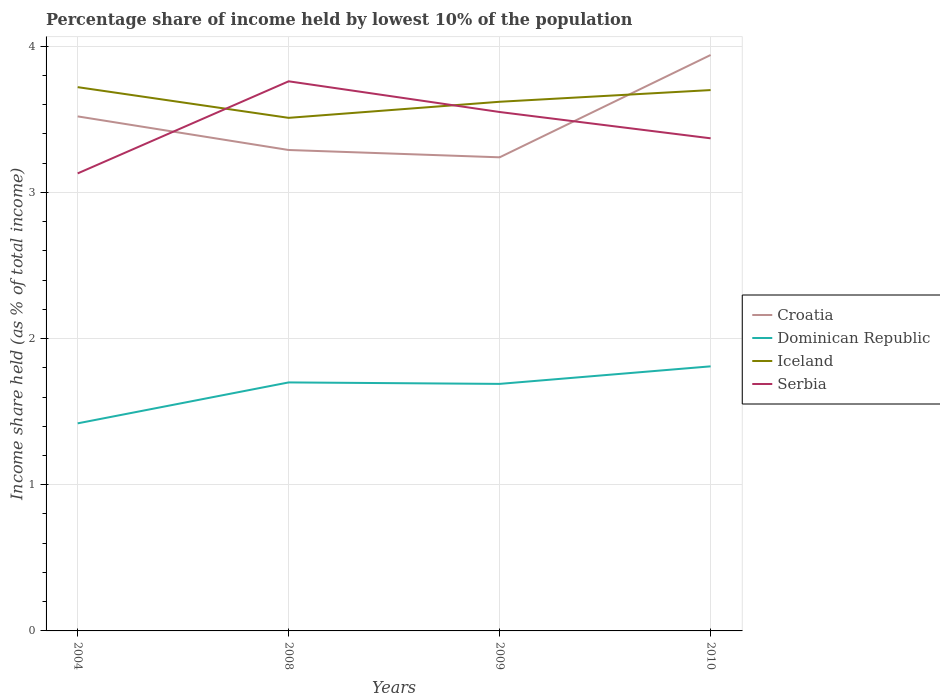How many different coloured lines are there?
Provide a succinct answer. 4. Does the line corresponding to Dominican Republic intersect with the line corresponding to Serbia?
Your response must be concise. No. Is the number of lines equal to the number of legend labels?
Give a very brief answer. Yes. Across all years, what is the maximum percentage share of income held by lowest 10% of the population in Croatia?
Offer a terse response. 3.24. In which year was the percentage share of income held by lowest 10% of the population in Iceland maximum?
Provide a short and direct response. 2008. What is the total percentage share of income held by lowest 10% of the population in Dominican Republic in the graph?
Your answer should be very brief. 0.01. What is the difference between the highest and the second highest percentage share of income held by lowest 10% of the population in Serbia?
Make the answer very short. 0.63. How many lines are there?
Your response must be concise. 4. How many years are there in the graph?
Keep it short and to the point. 4. Are the values on the major ticks of Y-axis written in scientific E-notation?
Offer a very short reply. No. Does the graph contain any zero values?
Your response must be concise. No. What is the title of the graph?
Keep it short and to the point. Percentage share of income held by lowest 10% of the population. Does "Gambia, The" appear as one of the legend labels in the graph?
Your answer should be very brief. No. What is the label or title of the Y-axis?
Your response must be concise. Income share held (as % of total income). What is the Income share held (as % of total income) in Croatia in 2004?
Give a very brief answer. 3.52. What is the Income share held (as % of total income) of Dominican Republic in 2004?
Offer a terse response. 1.42. What is the Income share held (as % of total income) of Iceland in 2004?
Your answer should be compact. 3.72. What is the Income share held (as % of total income) in Serbia in 2004?
Give a very brief answer. 3.13. What is the Income share held (as % of total income) in Croatia in 2008?
Offer a very short reply. 3.29. What is the Income share held (as % of total income) in Dominican Republic in 2008?
Provide a succinct answer. 1.7. What is the Income share held (as % of total income) in Iceland in 2008?
Offer a terse response. 3.51. What is the Income share held (as % of total income) in Serbia in 2008?
Keep it short and to the point. 3.76. What is the Income share held (as % of total income) in Croatia in 2009?
Give a very brief answer. 3.24. What is the Income share held (as % of total income) of Dominican Republic in 2009?
Keep it short and to the point. 1.69. What is the Income share held (as % of total income) in Iceland in 2009?
Offer a terse response. 3.62. What is the Income share held (as % of total income) of Serbia in 2009?
Your answer should be very brief. 3.55. What is the Income share held (as % of total income) of Croatia in 2010?
Keep it short and to the point. 3.94. What is the Income share held (as % of total income) in Dominican Republic in 2010?
Provide a short and direct response. 1.81. What is the Income share held (as % of total income) of Serbia in 2010?
Ensure brevity in your answer.  3.37. Across all years, what is the maximum Income share held (as % of total income) in Croatia?
Your answer should be very brief. 3.94. Across all years, what is the maximum Income share held (as % of total income) of Dominican Republic?
Offer a very short reply. 1.81. Across all years, what is the maximum Income share held (as % of total income) in Iceland?
Give a very brief answer. 3.72. Across all years, what is the maximum Income share held (as % of total income) in Serbia?
Your response must be concise. 3.76. Across all years, what is the minimum Income share held (as % of total income) of Croatia?
Ensure brevity in your answer.  3.24. Across all years, what is the minimum Income share held (as % of total income) of Dominican Republic?
Provide a succinct answer. 1.42. Across all years, what is the minimum Income share held (as % of total income) of Iceland?
Offer a very short reply. 3.51. Across all years, what is the minimum Income share held (as % of total income) of Serbia?
Your answer should be very brief. 3.13. What is the total Income share held (as % of total income) of Croatia in the graph?
Provide a short and direct response. 13.99. What is the total Income share held (as % of total income) of Dominican Republic in the graph?
Offer a very short reply. 6.62. What is the total Income share held (as % of total income) of Iceland in the graph?
Provide a short and direct response. 14.55. What is the total Income share held (as % of total income) of Serbia in the graph?
Provide a succinct answer. 13.81. What is the difference between the Income share held (as % of total income) of Croatia in 2004 and that in 2008?
Provide a succinct answer. 0.23. What is the difference between the Income share held (as % of total income) of Dominican Republic in 2004 and that in 2008?
Make the answer very short. -0.28. What is the difference between the Income share held (as % of total income) of Iceland in 2004 and that in 2008?
Give a very brief answer. 0.21. What is the difference between the Income share held (as % of total income) of Serbia in 2004 and that in 2008?
Make the answer very short. -0.63. What is the difference between the Income share held (as % of total income) of Croatia in 2004 and that in 2009?
Make the answer very short. 0.28. What is the difference between the Income share held (as % of total income) of Dominican Republic in 2004 and that in 2009?
Make the answer very short. -0.27. What is the difference between the Income share held (as % of total income) of Iceland in 2004 and that in 2009?
Make the answer very short. 0.1. What is the difference between the Income share held (as % of total income) of Serbia in 2004 and that in 2009?
Give a very brief answer. -0.42. What is the difference between the Income share held (as % of total income) in Croatia in 2004 and that in 2010?
Offer a terse response. -0.42. What is the difference between the Income share held (as % of total income) in Dominican Republic in 2004 and that in 2010?
Make the answer very short. -0.39. What is the difference between the Income share held (as % of total income) in Iceland in 2004 and that in 2010?
Keep it short and to the point. 0.02. What is the difference between the Income share held (as % of total income) in Serbia in 2004 and that in 2010?
Make the answer very short. -0.24. What is the difference between the Income share held (as % of total income) in Dominican Republic in 2008 and that in 2009?
Your response must be concise. 0.01. What is the difference between the Income share held (as % of total income) in Iceland in 2008 and that in 2009?
Provide a short and direct response. -0.11. What is the difference between the Income share held (as % of total income) in Serbia in 2008 and that in 2009?
Keep it short and to the point. 0.21. What is the difference between the Income share held (as % of total income) of Croatia in 2008 and that in 2010?
Provide a short and direct response. -0.65. What is the difference between the Income share held (as % of total income) of Dominican Republic in 2008 and that in 2010?
Your answer should be very brief. -0.11. What is the difference between the Income share held (as % of total income) in Iceland in 2008 and that in 2010?
Your answer should be very brief. -0.19. What is the difference between the Income share held (as % of total income) in Serbia in 2008 and that in 2010?
Your answer should be very brief. 0.39. What is the difference between the Income share held (as % of total income) of Dominican Republic in 2009 and that in 2010?
Offer a terse response. -0.12. What is the difference between the Income share held (as % of total income) of Iceland in 2009 and that in 2010?
Provide a succinct answer. -0.08. What is the difference between the Income share held (as % of total income) of Serbia in 2009 and that in 2010?
Give a very brief answer. 0.18. What is the difference between the Income share held (as % of total income) in Croatia in 2004 and the Income share held (as % of total income) in Dominican Republic in 2008?
Keep it short and to the point. 1.82. What is the difference between the Income share held (as % of total income) in Croatia in 2004 and the Income share held (as % of total income) in Serbia in 2008?
Your answer should be compact. -0.24. What is the difference between the Income share held (as % of total income) of Dominican Republic in 2004 and the Income share held (as % of total income) of Iceland in 2008?
Your answer should be compact. -2.09. What is the difference between the Income share held (as % of total income) of Dominican Republic in 2004 and the Income share held (as % of total income) of Serbia in 2008?
Ensure brevity in your answer.  -2.34. What is the difference between the Income share held (as % of total income) of Iceland in 2004 and the Income share held (as % of total income) of Serbia in 2008?
Your answer should be compact. -0.04. What is the difference between the Income share held (as % of total income) in Croatia in 2004 and the Income share held (as % of total income) in Dominican Republic in 2009?
Your response must be concise. 1.83. What is the difference between the Income share held (as % of total income) in Croatia in 2004 and the Income share held (as % of total income) in Iceland in 2009?
Keep it short and to the point. -0.1. What is the difference between the Income share held (as % of total income) in Croatia in 2004 and the Income share held (as % of total income) in Serbia in 2009?
Provide a short and direct response. -0.03. What is the difference between the Income share held (as % of total income) of Dominican Republic in 2004 and the Income share held (as % of total income) of Serbia in 2009?
Make the answer very short. -2.13. What is the difference between the Income share held (as % of total income) in Iceland in 2004 and the Income share held (as % of total income) in Serbia in 2009?
Keep it short and to the point. 0.17. What is the difference between the Income share held (as % of total income) of Croatia in 2004 and the Income share held (as % of total income) of Dominican Republic in 2010?
Keep it short and to the point. 1.71. What is the difference between the Income share held (as % of total income) of Croatia in 2004 and the Income share held (as % of total income) of Iceland in 2010?
Keep it short and to the point. -0.18. What is the difference between the Income share held (as % of total income) in Dominican Republic in 2004 and the Income share held (as % of total income) in Iceland in 2010?
Keep it short and to the point. -2.28. What is the difference between the Income share held (as % of total income) in Dominican Republic in 2004 and the Income share held (as % of total income) in Serbia in 2010?
Your answer should be compact. -1.95. What is the difference between the Income share held (as % of total income) in Croatia in 2008 and the Income share held (as % of total income) in Iceland in 2009?
Provide a short and direct response. -0.33. What is the difference between the Income share held (as % of total income) of Croatia in 2008 and the Income share held (as % of total income) of Serbia in 2009?
Offer a very short reply. -0.26. What is the difference between the Income share held (as % of total income) of Dominican Republic in 2008 and the Income share held (as % of total income) of Iceland in 2009?
Provide a short and direct response. -1.92. What is the difference between the Income share held (as % of total income) of Dominican Republic in 2008 and the Income share held (as % of total income) of Serbia in 2009?
Your answer should be compact. -1.85. What is the difference between the Income share held (as % of total income) of Iceland in 2008 and the Income share held (as % of total income) of Serbia in 2009?
Your response must be concise. -0.04. What is the difference between the Income share held (as % of total income) in Croatia in 2008 and the Income share held (as % of total income) in Dominican Republic in 2010?
Provide a succinct answer. 1.48. What is the difference between the Income share held (as % of total income) in Croatia in 2008 and the Income share held (as % of total income) in Iceland in 2010?
Provide a succinct answer. -0.41. What is the difference between the Income share held (as % of total income) of Croatia in 2008 and the Income share held (as % of total income) of Serbia in 2010?
Keep it short and to the point. -0.08. What is the difference between the Income share held (as % of total income) in Dominican Republic in 2008 and the Income share held (as % of total income) in Serbia in 2010?
Your answer should be compact. -1.67. What is the difference between the Income share held (as % of total income) of Iceland in 2008 and the Income share held (as % of total income) of Serbia in 2010?
Offer a terse response. 0.14. What is the difference between the Income share held (as % of total income) of Croatia in 2009 and the Income share held (as % of total income) of Dominican Republic in 2010?
Keep it short and to the point. 1.43. What is the difference between the Income share held (as % of total income) of Croatia in 2009 and the Income share held (as % of total income) of Iceland in 2010?
Ensure brevity in your answer.  -0.46. What is the difference between the Income share held (as % of total income) in Croatia in 2009 and the Income share held (as % of total income) in Serbia in 2010?
Offer a very short reply. -0.13. What is the difference between the Income share held (as % of total income) in Dominican Republic in 2009 and the Income share held (as % of total income) in Iceland in 2010?
Ensure brevity in your answer.  -2.01. What is the difference between the Income share held (as % of total income) in Dominican Republic in 2009 and the Income share held (as % of total income) in Serbia in 2010?
Your response must be concise. -1.68. What is the difference between the Income share held (as % of total income) of Iceland in 2009 and the Income share held (as % of total income) of Serbia in 2010?
Your answer should be very brief. 0.25. What is the average Income share held (as % of total income) in Croatia per year?
Provide a short and direct response. 3.5. What is the average Income share held (as % of total income) of Dominican Republic per year?
Offer a very short reply. 1.66. What is the average Income share held (as % of total income) of Iceland per year?
Keep it short and to the point. 3.64. What is the average Income share held (as % of total income) in Serbia per year?
Ensure brevity in your answer.  3.45. In the year 2004, what is the difference between the Income share held (as % of total income) of Croatia and Income share held (as % of total income) of Dominican Republic?
Provide a succinct answer. 2.1. In the year 2004, what is the difference between the Income share held (as % of total income) in Croatia and Income share held (as % of total income) in Iceland?
Provide a short and direct response. -0.2. In the year 2004, what is the difference between the Income share held (as % of total income) in Croatia and Income share held (as % of total income) in Serbia?
Your response must be concise. 0.39. In the year 2004, what is the difference between the Income share held (as % of total income) of Dominican Republic and Income share held (as % of total income) of Iceland?
Keep it short and to the point. -2.3. In the year 2004, what is the difference between the Income share held (as % of total income) in Dominican Republic and Income share held (as % of total income) in Serbia?
Ensure brevity in your answer.  -1.71. In the year 2004, what is the difference between the Income share held (as % of total income) of Iceland and Income share held (as % of total income) of Serbia?
Provide a short and direct response. 0.59. In the year 2008, what is the difference between the Income share held (as % of total income) in Croatia and Income share held (as % of total income) in Dominican Republic?
Provide a short and direct response. 1.59. In the year 2008, what is the difference between the Income share held (as % of total income) of Croatia and Income share held (as % of total income) of Iceland?
Offer a terse response. -0.22. In the year 2008, what is the difference between the Income share held (as % of total income) in Croatia and Income share held (as % of total income) in Serbia?
Your answer should be very brief. -0.47. In the year 2008, what is the difference between the Income share held (as % of total income) in Dominican Republic and Income share held (as % of total income) in Iceland?
Give a very brief answer. -1.81. In the year 2008, what is the difference between the Income share held (as % of total income) in Dominican Republic and Income share held (as % of total income) in Serbia?
Your response must be concise. -2.06. In the year 2008, what is the difference between the Income share held (as % of total income) in Iceland and Income share held (as % of total income) in Serbia?
Your answer should be compact. -0.25. In the year 2009, what is the difference between the Income share held (as % of total income) in Croatia and Income share held (as % of total income) in Dominican Republic?
Your answer should be very brief. 1.55. In the year 2009, what is the difference between the Income share held (as % of total income) in Croatia and Income share held (as % of total income) in Iceland?
Your answer should be compact. -0.38. In the year 2009, what is the difference between the Income share held (as % of total income) of Croatia and Income share held (as % of total income) of Serbia?
Your answer should be very brief. -0.31. In the year 2009, what is the difference between the Income share held (as % of total income) of Dominican Republic and Income share held (as % of total income) of Iceland?
Give a very brief answer. -1.93. In the year 2009, what is the difference between the Income share held (as % of total income) of Dominican Republic and Income share held (as % of total income) of Serbia?
Ensure brevity in your answer.  -1.86. In the year 2009, what is the difference between the Income share held (as % of total income) in Iceland and Income share held (as % of total income) in Serbia?
Provide a short and direct response. 0.07. In the year 2010, what is the difference between the Income share held (as % of total income) in Croatia and Income share held (as % of total income) in Dominican Republic?
Offer a very short reply. 2.13. In the year 2010, what is the difference between the Income share held (as % of total income) in Croatia and Income share held (as % of total income) in Iceland?
Provide a succinct answer. 0.24. In the year 2010, what is the difference between the Income share held (as % of total income) in Croatia and Income share held (as % of total income) in Serbia?
Provide a short and direct response. 0.57. In the year 2010, what is the difference between the Income share held (as % of total income) in Dominican Republic and Income share held (as % of total income) in Iceland?
Your answer should be compact. -1.89. In the year 2010, what is the difference between the Income share held (as % of total income) of Dominican Republic and Income share held (as % of total income) of Serbia?
Your answer should be very brief. -1.56. In the year 2010, what is the difference between the Income share held (as % of total income) of Iceland and Income share held (as % of total income) of Serbia?
Give a very brief answer. 0.33. What is the ratio of the Income share held (as % of total income) in Croatia in 2004 to that in 2008?
Offer a terse response. 1.07. What is the ratio of the Income share held (as % of total income) in Dominican Republic in 2004 to that in 2008?
Your answer should be compact. 0.84. What is the ratio of the Income share held (as % of total income) of Iceland in 2004 to that in 2008?
Provide a succinct answer. 1.06. What is the ratio of the Income share held (as % of total income) of Serbia in 2004 to that in 2008?
Provide a succinct answer. 0.83. What is the ratio of the Income share held (as % of total income) in Croatia in 2004 to that in 2009?
Make the answer very short. 1.09. What is the ratio of the Income share held (as % of total income) in Dominican Republic in 2004 to that in 2009?
Your answer should be compact. 0.84. What is the ratio of the Income share held (as % of total income) in Iceland in 2004 to that in 2009?
Give a very brief answer. 1.03. What is the ratio of the Income share held (as % of total income) of Serbia in 2004 to that in 2009?
Provide a short and direct response. 0.88. What is the ratio of the Income share held (as % of total income) in Croatia in 2004 to that in 2010?
Ensure brevity in your answer.  0.89. What is the ratio of the Income share held (as % of total income) in Dominican Republic in 2004 to that in 2010?
Your answer should be compact. 0.78. What is the ratio of the Income share held (as % of total income) of Iceland in 2004 to that in 2010?
Give a very brief answer. 1.01. What is the ratio of the Income share held (as % of total income) in Serbia in 2004 to that in 2010?
Your response must be concise. 0.93. What is the ratio of the Income share held (as % of total income) of Croatia in 2008 to that in 2009?
Offer a very short reply. 1.02. What is the ratio of the Income share held (as % of total income) of Dominican Republic in 2008 to that in 2009?
Provide a short and direct response. 1.01. What is the ratio of the Income share held (as % of total income) of Iceland in 2008 to that in 2009?
Provide a succinct answer. 0.97. What is the ratio of the Income share held (as % of total income) in Serbia in 2008 to that in 2009?
Give a very brief answer. 1.06. What is the ratio of the Income share held (as % of total income) of Croatia in 2008 to that in 2010?
Keep it short and to the point. 0.83. What is the ratio of the Income share held (as % of total income) of Dominican Republic in 2008 to that in 2010?
Provide a short and direct response. 0.94. What is the ratio of the Income share held (as % of total income) in Iceland in 2008 to that in 2010?
Ensure brevity in your answer.  0.95. What is the ratio of the Income share held (as % of total income) in Serbia in 2008 to that in 2010?
Give a very brief answer. 1.12. What is the ratio of the Income share held (as % of total income) in Croatia in 2009 to that in 2010?
Provide a short and direct response. 0.82. What is the ratio of the Income share held (as % of total income) of Dominican Republic in 2009 to that in 2010?
Provide a succinct answer. 0.93. What is the ratio of the Income share held (as % of total income) in Iceland in 2009 to that in 2010?
Offer a terse response. 0.98. What is the ratio of the Income share held (as % of total income) of Serbia in 2009 to that in 2010?
Make the answer very short. 1.05. What is the difference between the highest and the second highest Income share held (as % of total income) of Croatia?
Give a very brief answer. 0.42. What is the difference between the highest and the second highest Income share held (as % of total income) of Dominican Republic?
Your response must be concise. 0.11. What is the difference between the highest and the second highest Income share held (as % of total income) in Serbia?
Your answer should be very brief. 0.21. What is the difference between the highest and the lowest Income share held (as % of total income) of Croatia?
Give a very brief answer. 0.7. What is the difference between the highest and the lowest Income share held (as % of total income) in Dominican Republic?
Your answer should be very brief. 0.39. What is the difference between the highest and the lowest Income share held (as % of total income) in Iceland?
Your answer should be very brief. 0.21. What is the difference between the highest and the lowest Income share held (as % of total income) of Serbia?
Your answer should be compact. 0.63. 